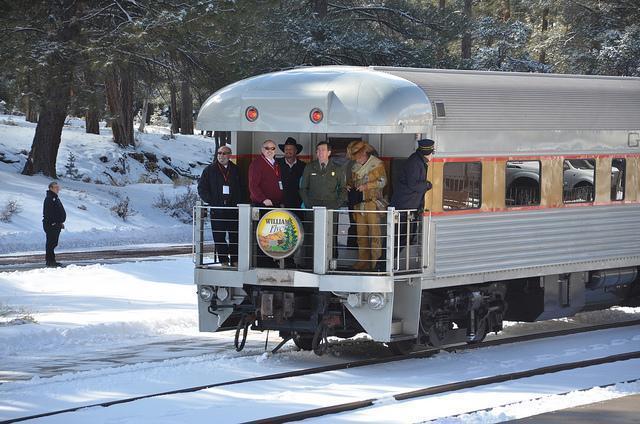How many people are in the picture?
Give a very brief answer. 4. How many bears are licking their paws?
Give a very brief answer. 0. 